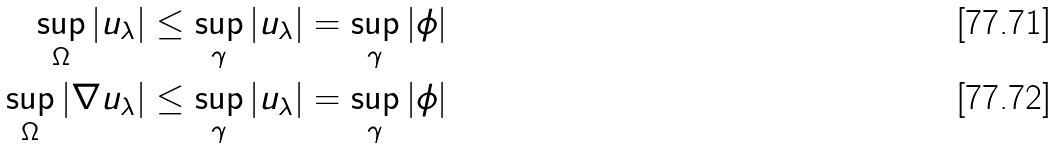<formula> <loc_0><loc_0><loc_500><loc_500>\sup _ { \Omega } | u _ { \lambda } | & \leq \sup _ { \gamma } | u _ { \lambda } | = \sup _ { \gamma } | \phi | \\ \sup _ { \Omega } | \nabla u _ { \lambda } | & \leq \sup _ { \gamma } | u _ { \lambda } | = \sup _ { \gamma } | \phi |</formula> 